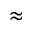<formula> <loc_0><loc_0><loc_500><loc_500>\approx</formula> 